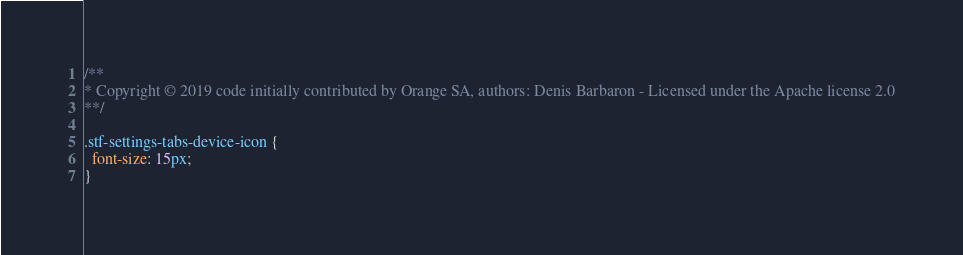Convert code to text. <code><loc_0><loc_0><loc_500><loc_500><_CSS_>/**
* Copyright © 2019 code initially contributed by Orange SA, authors: Denis Barbaron - Licensed under the Apache license 2.0
**/

.stf-settings-tabs-device-icon {
  font-size: 15px;
}

</code> 